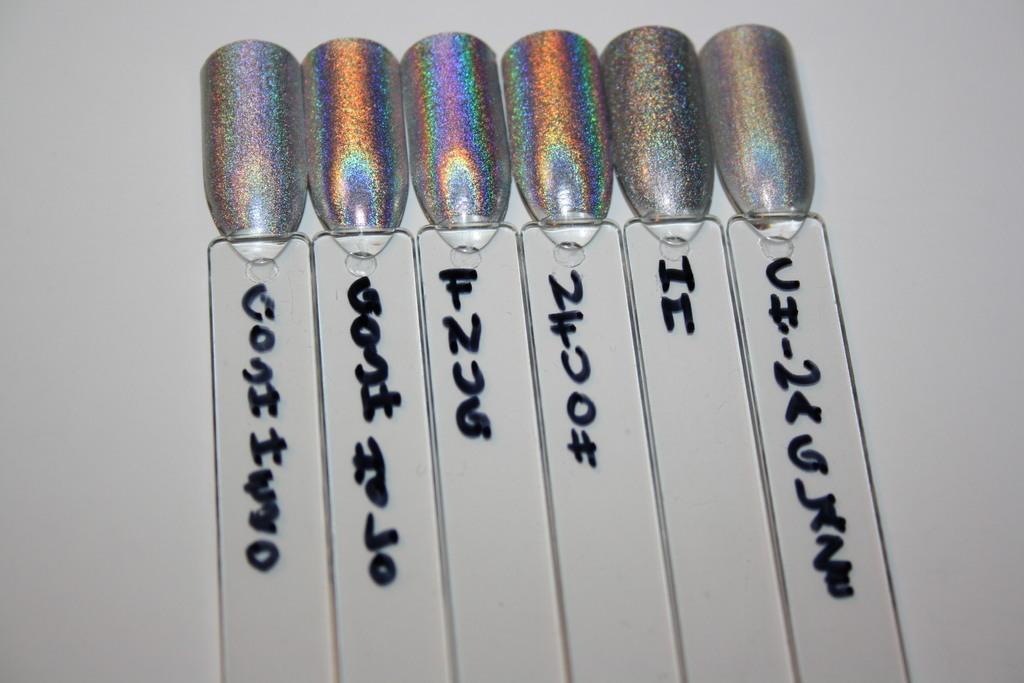In one or two sentences, can you explain what this image depicts? In this image there is some text written on some objects. 